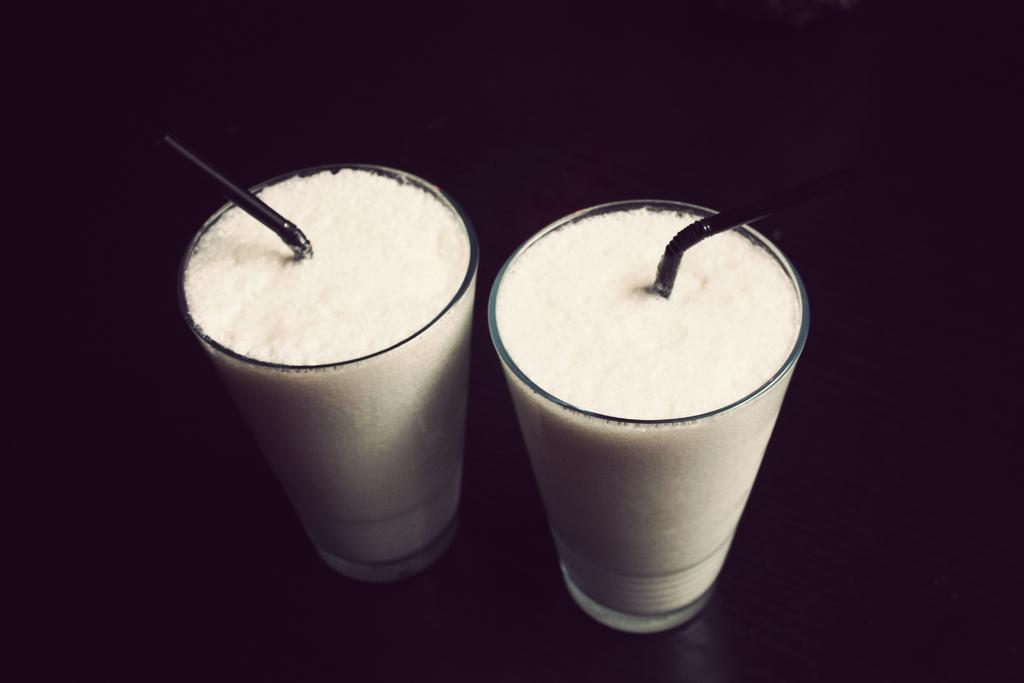How many glasses are visible in the image? There are two glasses in the image. What feature do the glasses have? The glasses have straws. What color is the surface beneath the glasses? The surface beneath the glasses is black. How many dogs are playing with a cub in the image? There are no dogs or cubs present in the image. Is there a rifle visible in the image? There is no rifle present in the image. 